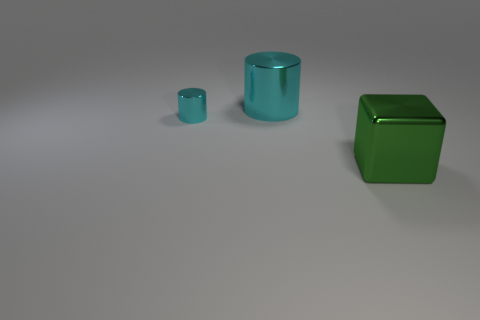There is a big metal thing that is to the left of the green object; is it the same shape as the big green thing in front of the big shiny cylinder?
Give a very brief answer. No. What number of other things are there of the same color as the shiny cube?
Keep it short and to the point. 0. Do the big object behind the big green metallic object and the large thing that is to the right of the large cyan cylinder have the same material?
Your answer should be very brief. Yes. Is the number of green shiny things that are behind the small cylinder the same as the number of green shiny things in front of the large green cube?
Your response must be concise. Yes. There is a large thing behind the small cylinder; what is it made of?
Offer a terse response. Metal. Are there any other things that have the same size as the metallic cube?
Offer a very short reply. Yes. Is the number of green shiny things less than the number of tiny gray metallic balls?
Your answer should be compact. No. What shape is the object that is in front of the large shiny cylinder and behind the big shiny cube?
Ensure brevity in your answer.  Cylinder. How many green cubes are there?
Your answer should be compact. 1. There is a cylinder that is behind the cyan cylinder left of the cyan cylinder to the right of the small cyan cylinder; what is it made of?
Make the answer very short. Metal. 